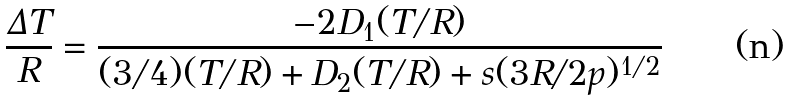Convert formula to latex. <formula><loc_0><loc_0><loc_500><loc_500>\frac { \Delta T } { R } = \frac { - 2 D _ { 1 } ( T / R ) } { ( 3 / 4 ) ( T / R ) + D _ { 2 } ( T / R ) + s ( 3 R / 2 p ) ^ { 1 / 2 } }</formula> 